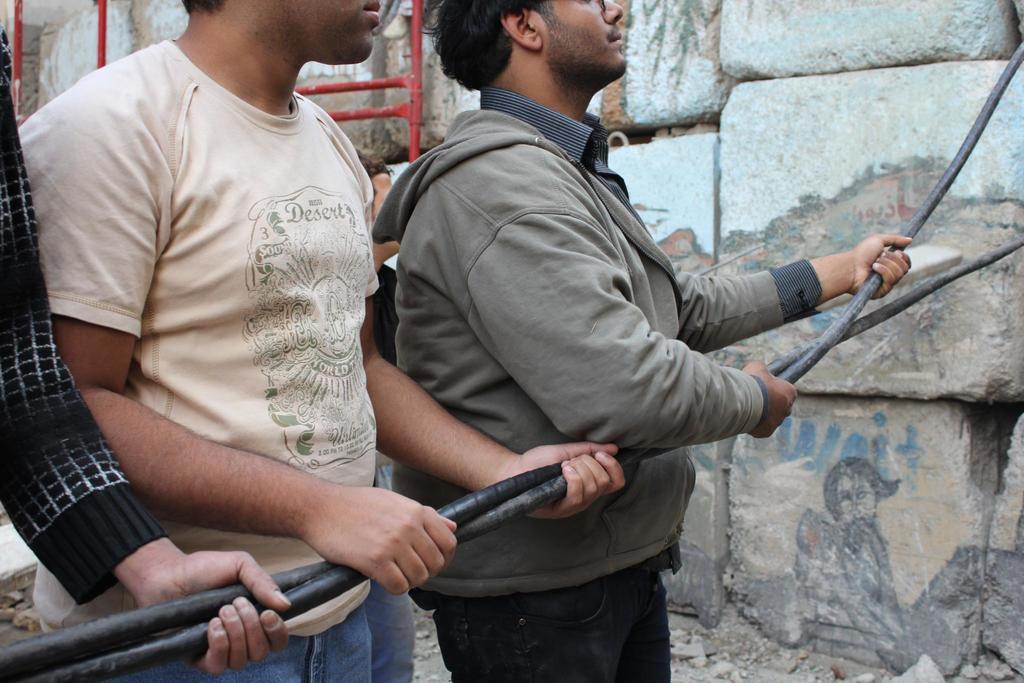How many people are present in the image? There are three people in the image. What are the three people holding? The three people are holding pipes. Can you describe the background of the image? There is a person, rods, and stones visible in the background of the image. What type of worm can be seen crawling on the stones in the image? There is no worm present in the image; only people, pipes, a person in the background, rods, and stones are visible. 